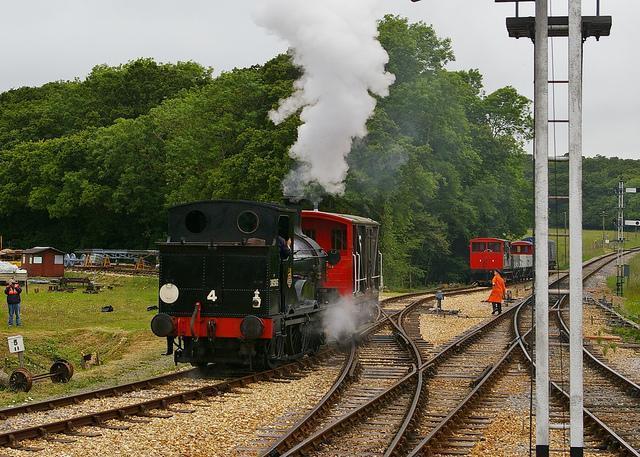How many trains are there?
Give a very brief answer. 2. How many pieces of broccoli are pointed flower side towards the camera?
Give a very brief answer. 0. 